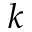<formula> <loc_0><loc_0><loc_500><loc_500>k</formula> 